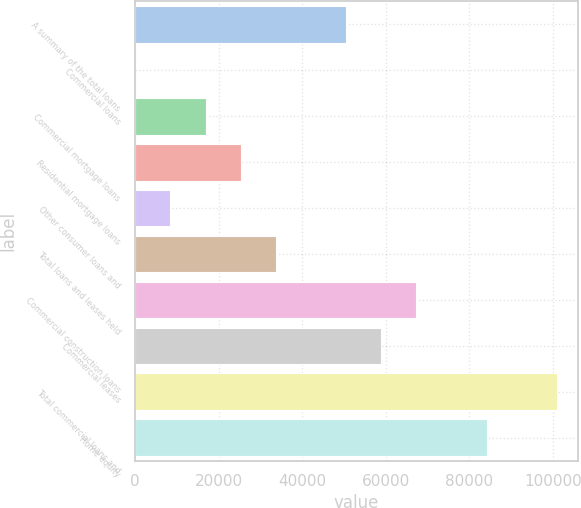Convert chart. <chart><loc_0><loc_0><loc_500><loc_500><bar_chart><fcel>A summary of the total loans<fcel>Commercial loans<fcel>Commercial mortgage loans<fcel>Residential mortgage loans<fcel>Other consumer loans and<fcel>Total loans and leases held<fcel>Commercial construction loans<fcel>Commercial leases<fcel>Total commercial loans and<fcel>Home equity<nl><fcel>50495<fcel>23<fcel>16847<fcel>25259<fcel>8435<fcel>33671<fcel>67319<fcel>58907<fcel>100967<fcel>84143<nl></chart> 